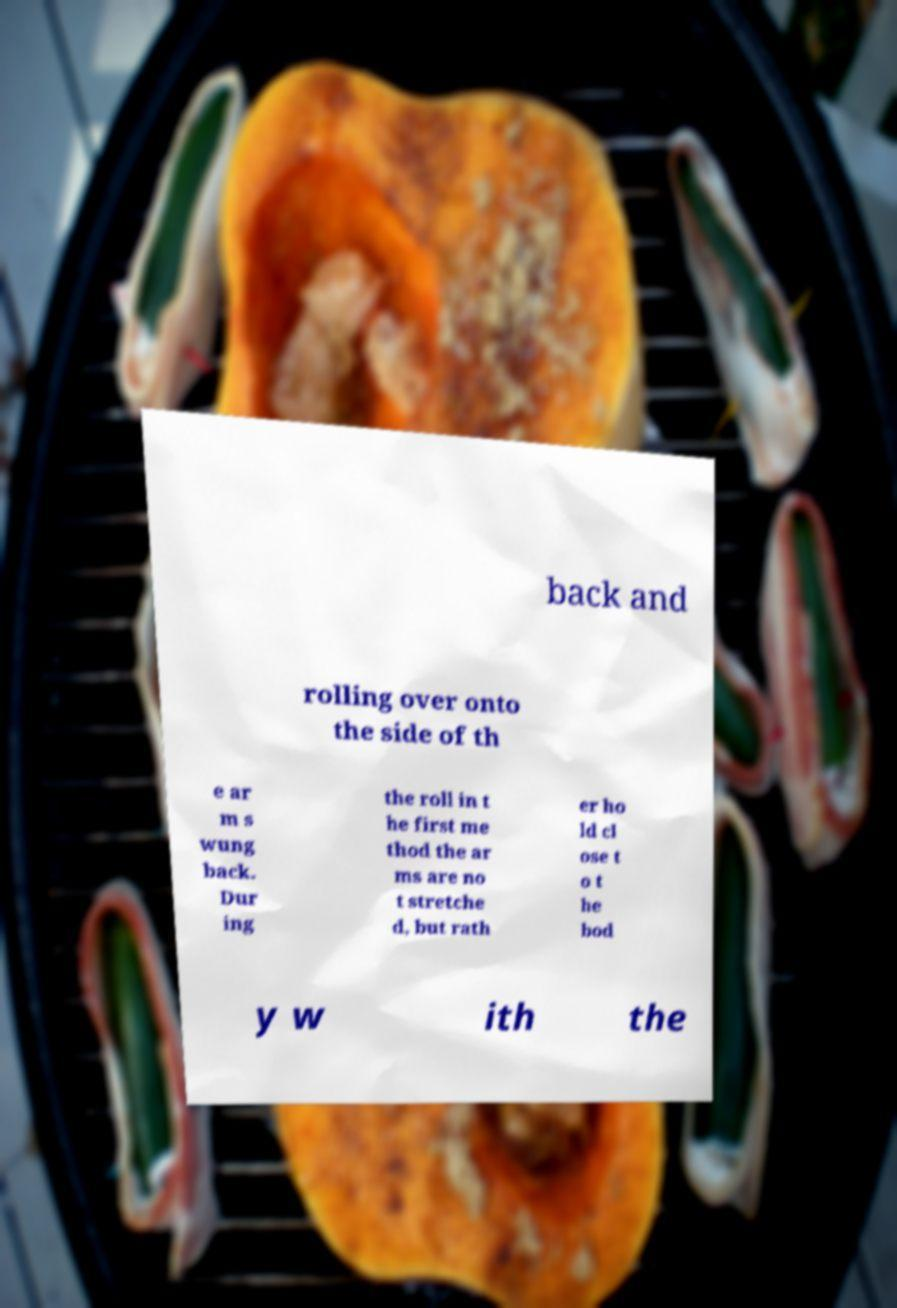Can you accurately transcribe the text from the provided image for me? back and rolling over onto the side of th e ar m s wung back. Dur ing the roll in t he first me thod the ar ms are no t stretche d, but rath er ho ld cl ose t o t he bod y w ith the 